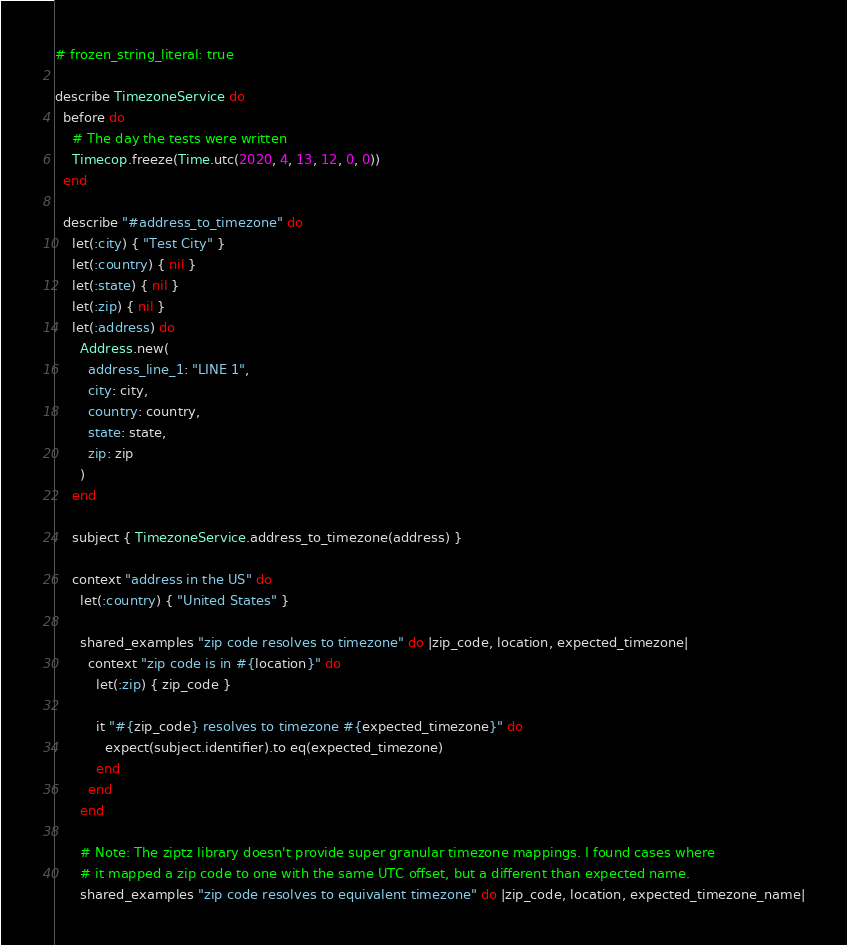Convert code to text. <code><loc_0><loc_0><loc_500><loc_500><_Ruby_># frozen_string_literal: true

describe TimezoneService do
  before do
    # The day the tests were written
    Timecop.freeze(Time.utc(2020, 4, 13, 12, 0, 0))
  end

  describe "#address_to_timezone" do
    let(:city) { "Test City" }
    let(:country) { nil }
    let(:state) { nil }
    let(:zip) { nil }
    let(:address) do
      Address.new(
        address_line_1: "LINE 1",
        city: city,
        country: country,
        state: state,
        zip: zip
      )
    end

    subject { TimezoneService.address_to_timezone(address) }

    context "address in the US" do
      let(:country) { "United States" }

      shared_examples "zip code resolves to timezone" do |zip_code, location, expected_timezone|
        context "zip code is in #{location}" do
          let(:zip) { zip_code }

          it "#{zip_code} resolves to timezone #{expected_timezone}" do
            expect(subject.identifier).to eq(expected_timezone)
          end
        end
      end

      # Note: The ziptz library doesn't provide super granular timezone mappings. I found cases where
      # it mapped a zip code to one with the same UTC offset, but a different than expected name.
      shared_examples "zip code resolves to equivalent timezone" do |zip_code, location, expected_timezone_name|</code> 